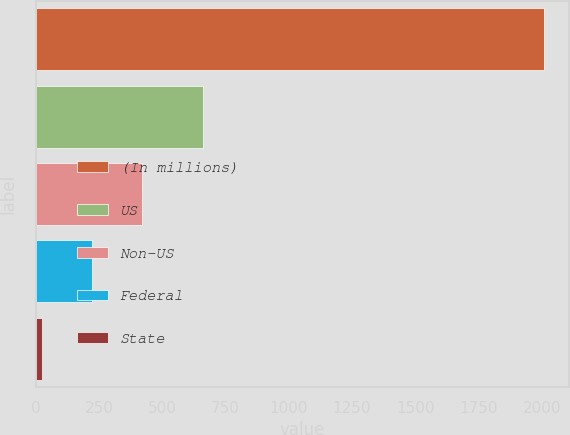Convert chart to OTSL. <chart><loc_0><loc_0><loc_500><loc_500><bar_chart><fcel>(In millions)<fcel>US<fcel>Non-US<fcel>Federal<fcel>State<nl><fcel>2007<fcel>660.5<fcel>421<fcel>222.75<fcel>24.5<nl></chart> 